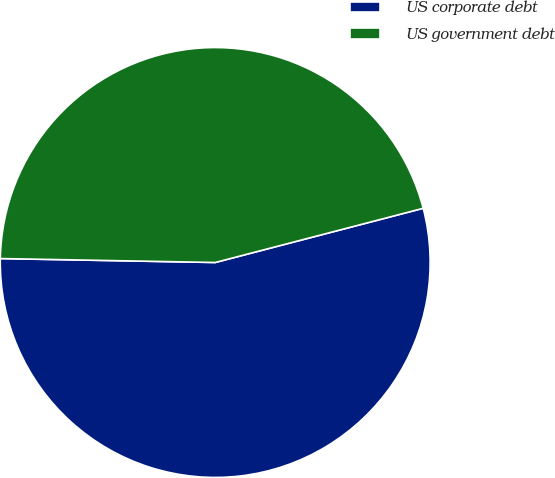Convert chart. <chart><loc_0><loc_0><loc_500><loc_500><pie_chart><fcel>US corporate debt<fcel>US government debt<nl><fcel>54.35%<fcel>45.65%<nl></chart> 